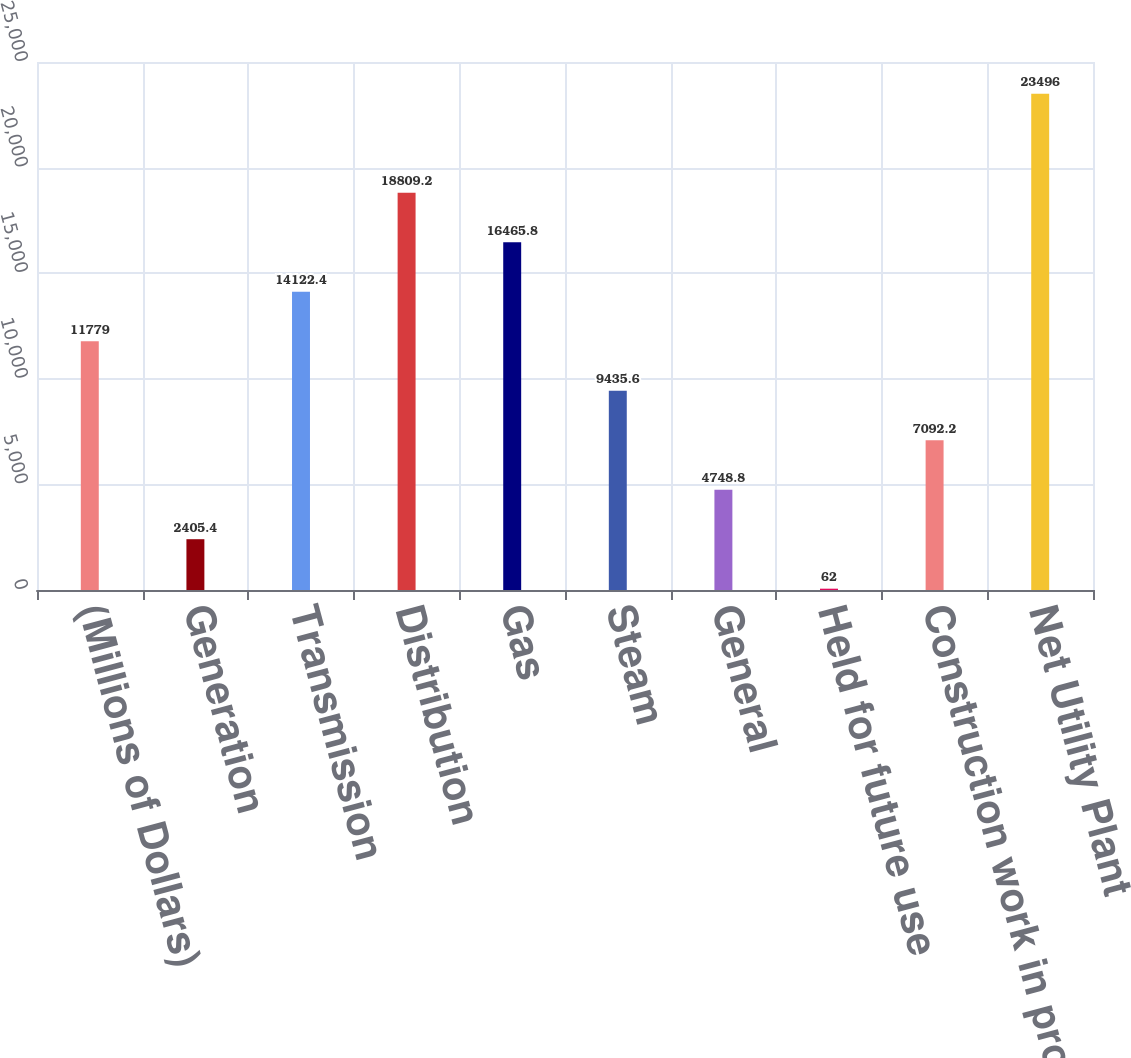Convert chart. <chart><loc_0><loc_0><loc_500><loc_500><bar_chart><fcel>(Millions of Dollars)<fcel>Generation<fcel>Transmission<fcel>Distribution<fcel>Gas<fcel>Steam<fcel>General<fcel>Held for future use<fcel>Construction work in progress<fcel>Net Utility Plant<nl><fcel>11779<fcel>2405.4<fcel>14122.4<fcel>18809.2<fcel>16465.8<fcel>9435.6<fcel>4748.8<fcel>62<fcel>7092.2<fcel>23496<nl></chart> 